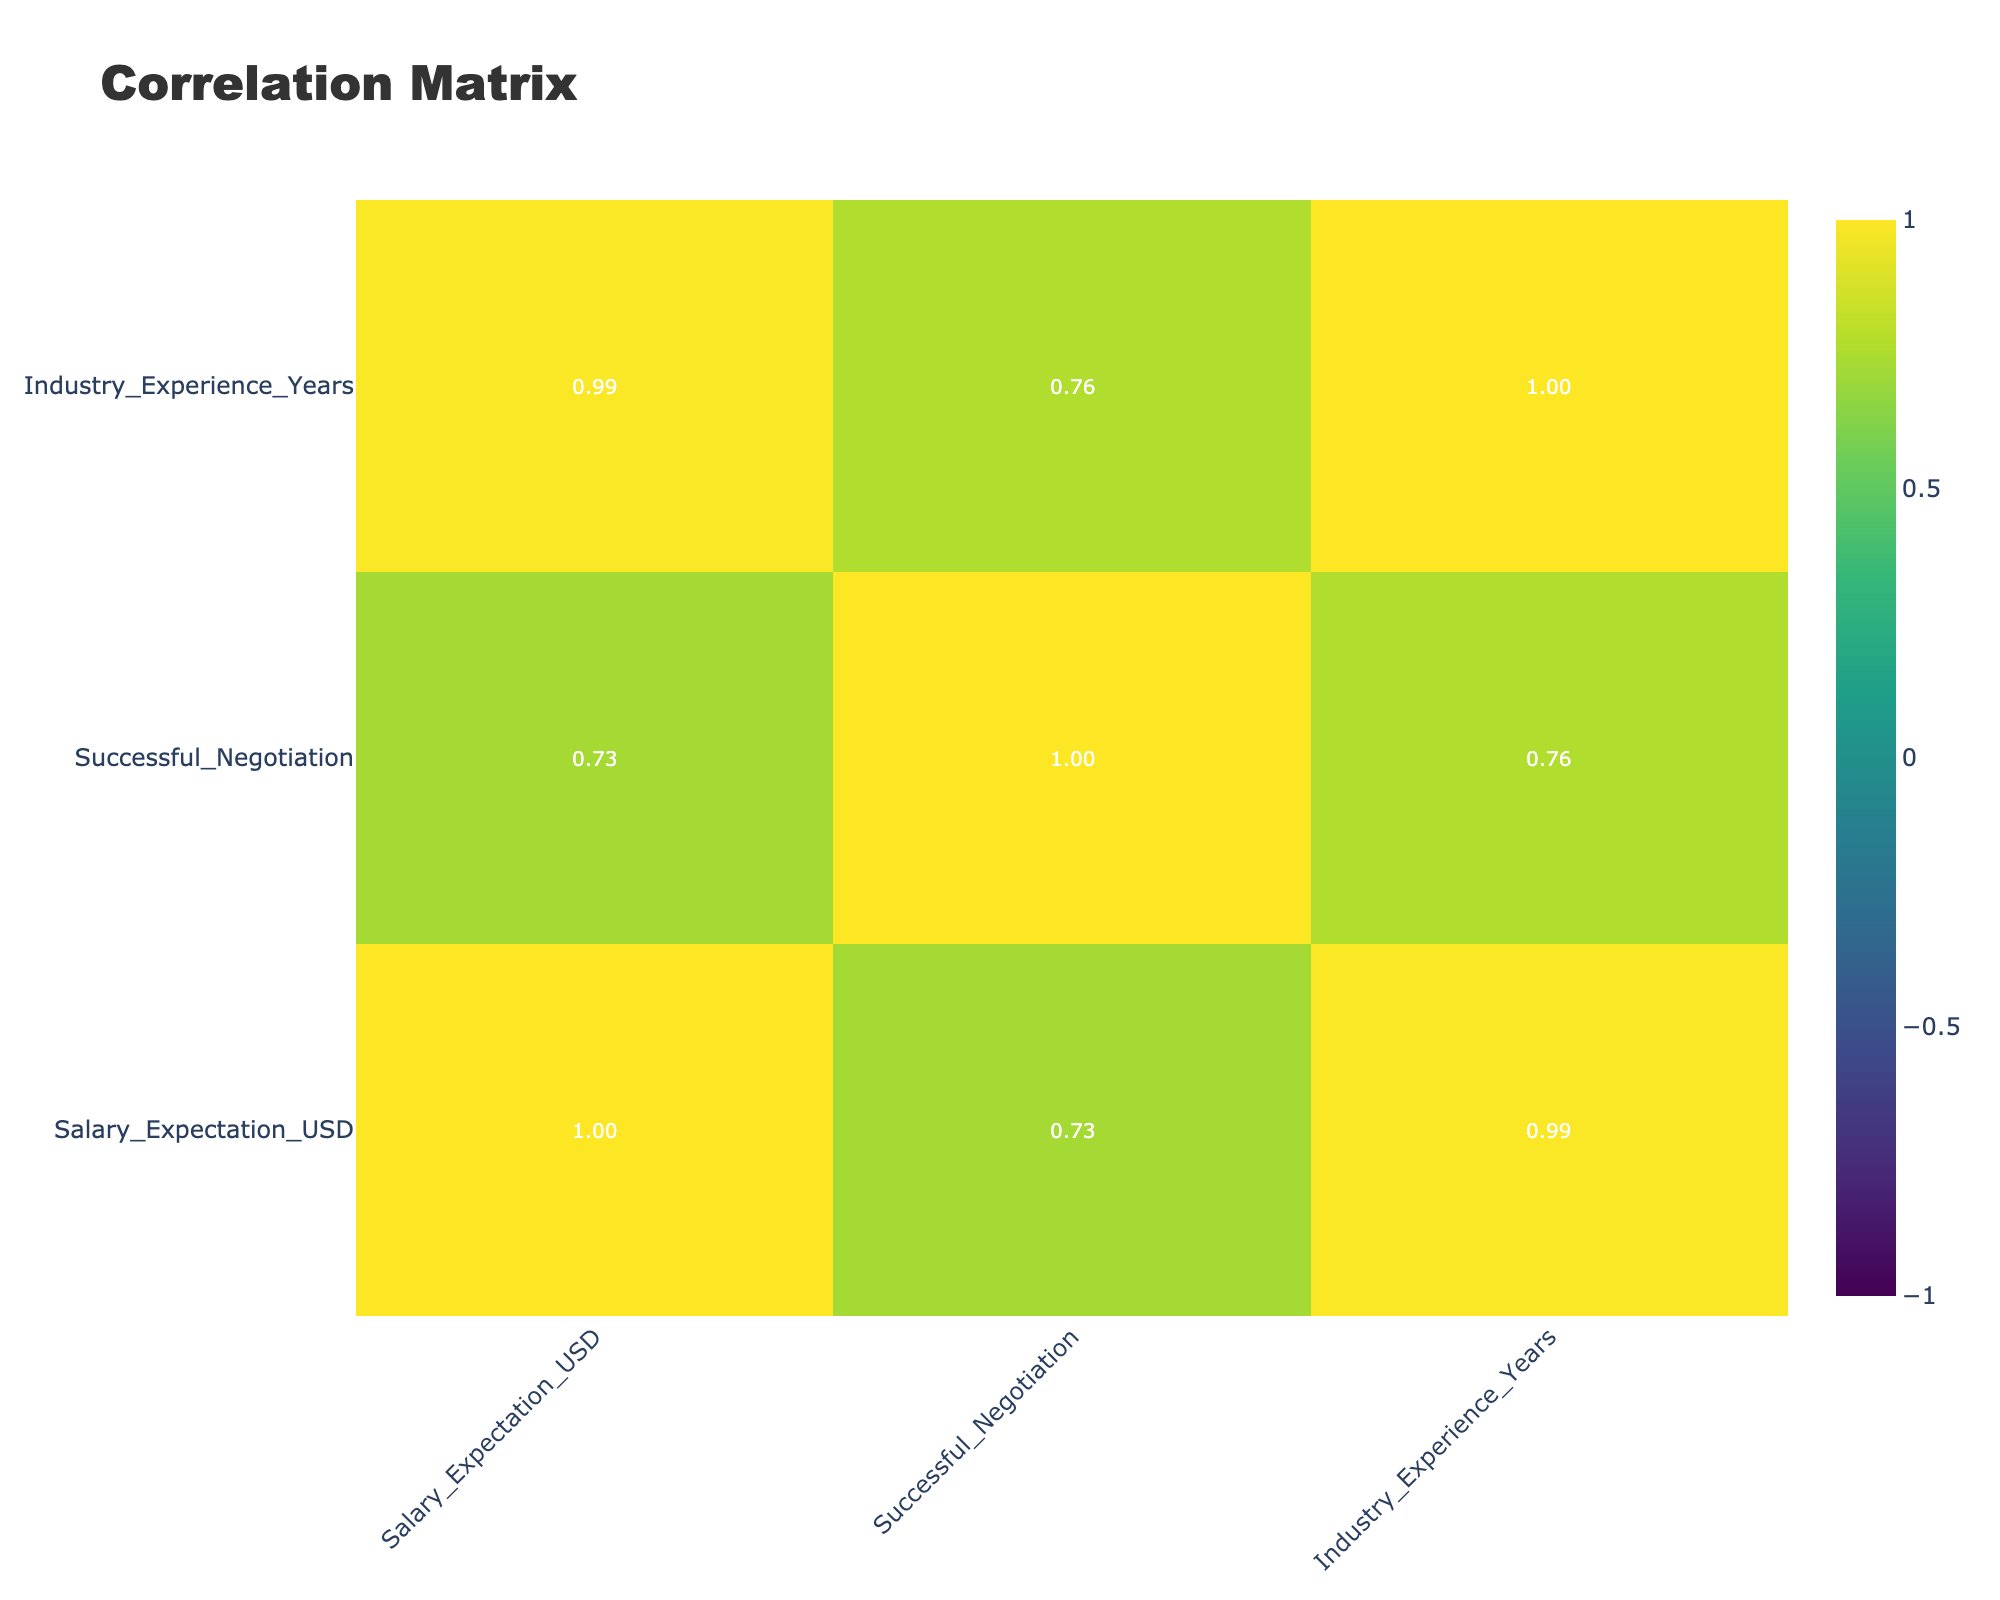What is the average salary expectation for fluent speakers? There are three entries for fluent speakers with salary expectations of 80000, 95000, and 85000. To find the average, sum these values: 80000 + 95000 + 85000 = 260000. Then divide by the number of entries: 260000 / 3 = 86666.67. Rounded to the nearest dollar, the average is 86667.
Answer: 86667 Is there any language fluency that has a higher successful negotiation rate than fluent speakers? The successful negotiation rates are as follows: fluent has 3 successes out of 3, conversational has 3 successes out of 6, and basic has 0 successes out of 3. Only fluent speakers have a 100% success rate, which is higher than the other fluency levels.
Answer: No What is the total number of successful negotiations for conversational speakers? There are 3 successful negotiations listed under conversational speakers (one in mid-level developer, one in customer service rep, and none among the rest). Thus, the total count is straightforward: 1 + 1 + 0 = 2.
Answer: 2 Does having industry experience impact the successful negotiation outcomes for fluent speakers? For fluent speakers, all three have successful negotiations regardless of their industry experience years (10, 12, 8). This suggests that for fluent speakers, the industry experience level does not seem to impact their success rate, as it remains constant at 100%.
Answer: No What is the difference in average salary expectations between fluent and basic speakers? The average salary expectation for fluent speakers is 86667, while the basic speakers' expectations average at 48000. To find the difference: 86667 - 48000 = 38667.
Answer: 38667 Are all basic speakers unsuccessful in negotiations? All entries for basic speakers report 0 successful negotiations based on the provided data. Thus, it is indeed true that none were successful.
Answer: Yes What percentage of conversational speakers were successful in their negotiations? There are a total of 6 conversational speakers, with 3 successful negotiations (one in mid-level developer, one in customer service rep, and one that was unsuccessful). The percentage is calculated as (3 / 6) * 100 = 50%.
Answer: 50% How does the successful negotiation outcome compare between fluent and conversational speakers? Among fluent speakers, all have successful negotiations, which gives a success rate of 100%. Conversely, conversational speakers have a success rate of 50% (3 of 6 were successful). Thus, fluent speakers have a significantly higher success rate in negotiations.
Answer: Fluent speakers have a higher success rate 